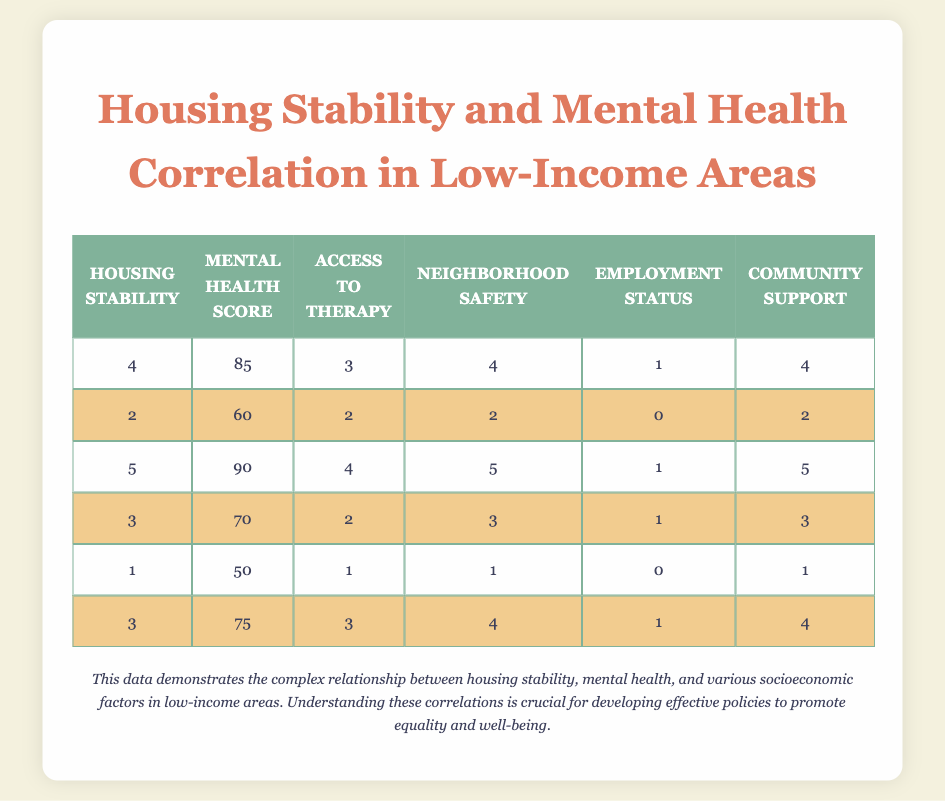What is the highest Housing Stability score in the table? Looking at the Housing Stability column, the maximum value is 5, which occurs in the third row.
Answer: 5 What is the Mental Health Score of the individual with the lowest Housing Stability? The individual with the lowest Housing Stability score has a score of 50, which can be found in the last row.
Answer: 50 Is there a row where both Access to Therapy and Neighborhood Safety have the same score? In the fourth row, both Access to Therapy and Neighborhood Safety have a score of 2. Therefore, this is true.
Answer: Yes What is the average Mental Health Score for individuals with a Housing Stability score of 3? The Mental Health Scores corresponding to Housing Stability of 3 are 70 and 75. Summing these gives 145. Since there are two entries, the average is 145/2 = 72.5.
Answer: 72.5 Does higher Community Support correlate with higher Mental Health Scores based on this data? Analyzing the table reveals that when Community Support increases, Mental Health Scores often increase too, indicating a positive correlation.
Answer: Yes What is the difference between the highest and lowest Access to Therapy scores? The highest Access to Therapy score is 4 (from the third row) and the lowest is 1 (from the last row). The difference is 4 - 1 = 3.
Answer: 3 What is the most common Employment Status score in the table? The Employment Status values are 1, 0, 1, 1, 0, and 1. The score of 1 appears most frequently (four times).
Answer: 1 How many individuals have a Mental Health Score of 75 or higher? The Mental Health Scores that are 75 or higher are 85, 90, and 75, which means three individuals meet this criterion.
Answer: 3 What is the combined total score of Neighborhood Safety for individuals with a Housing Stability score of 2? Looking at the rows with Housing Stability 2, the Neighborhood Safety score is 2, giving a total of 2 for that row.
Answer: 2 